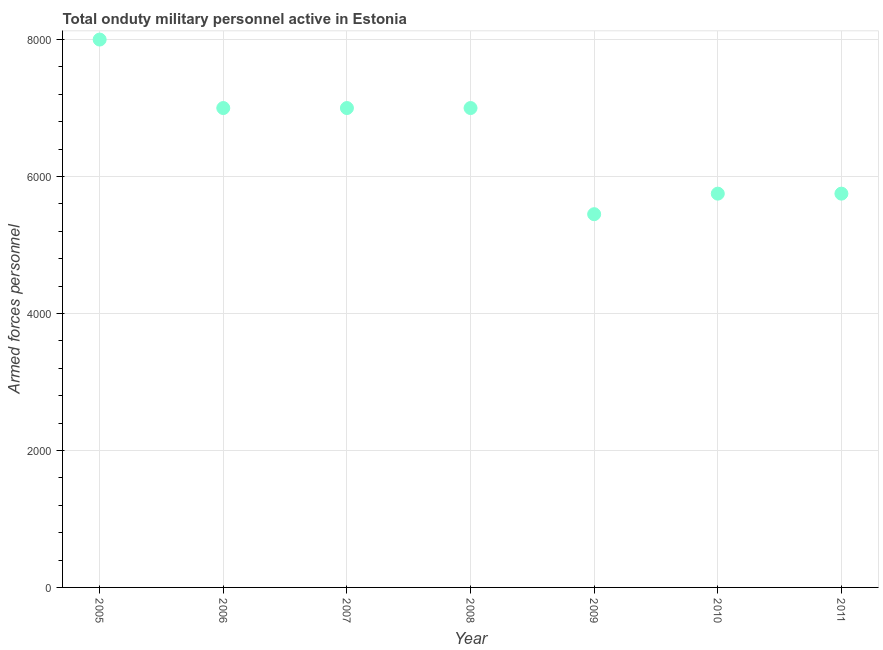What is the number of armed forces personnel in 2006?
Offer a very short reply. 7000. Across all years, what is the maximum number of armed forces personnel?
Provide a short and direct response. 8000. Across all years, what is the minimum number of armed forces personnel?
Your response must be concise. 5450. What is the sum of the number of armed forces personnel?
Give a very brief answer. 4.60e+04. What is the difference between the number of armed forces personnel in 2005 and 2006?
Provide a short and direct response. 1000. What is the average number of armed forces personnel per year?
Offer a very short reply. 6564.29. What is the median number of armed forces personnel?
Offer a terse response. 7000. In how many years, is the number of armed forces personnel greater than 1600 ?
Keep it short and to the point. 7. What is the ratio of the number of armed forces personnel in 2005 to that in 2010?
Your response must be concise. 1.39. Is the number of armed forces personnel in 2006 less than that in 2008?
Provide a succinct answer. No. Is the difference between the number of armed forces personnel in 2005 and 2011 greater than the difference between any two years?
Your answer should be very brief. No. What is the difference between the highest and the second highest number of armed forces personnel?
Keep it short and to the point. 1000. What is the difference between the highest and the lowest number of armed forces personnel?
Keep it short and to the point. 2550. In how many years, is the number of armed forces personnel greater than the average number of armed forces personnel taken over all years?
Keep it short and to the point. 4. How many dotlines are there?
Your answer should be very brief. 1. How many years are there in the graph?
Give a very brief answer. 7. Does the graph contain grids?
Provide a short and direct response. Yes. What is the title of the graph?
Give a very brief answer. Total onduty military personnel active in Estonia. What is the label or title of the X-axis?
Give a very brief answer. Year. What is the label or title of the Y-axis?
Provide a succinct answer. Armed forces personnel. What is the Armed forces personnel in 2005?
Your answer should be compact. 8000. What is the Armed forces personnel in 2006?
Your answer should be very brief. 7000. What is the Armed forces personnel in 2007?
Ensure brevity in your answer.  7000. What is the Armed forces personnel in 2008?
Provide a short and direct response. 7000. What is the Armed forces personnel in 2009?
Give a very brief answer. 5450. What is the Armed forces personnel in 2010?
Ensure brevity in your answer.  5750. What is the Armed forces personnel in 2011?
Offer a terse response. 5750. What is the difference between the Armed forces personnel in 2005 and 2006?
Provide a succinct answer. 1000. What is the difference between the Armed forces personnel in 2005 and 2007?
Ensure brevity in your answer.  1000. What is the difference between the Armed forces personnel in 2005 and 2008?
Offer a terse response. 1000. What is the difference between the Armed forces personnel in 2005 and 2009?
Your answer should be very brief. 2550. What is the difference between the Armed forces personnel in 2005 and 2010?
Give a very brief answer. 2250. What is the difference between the Armed forces personnel in 2005 and 2011?
Offer a terse response. 2250. What is the difference between the Armed forces personnel in 2006 and 2009?
Give a very brief answer. 1550. What is the difference between the Armed forces personnel in 2006 and 2010?
Your response must be concise. 1250. What is the difference between the Armed forces personnel in 2006 and 2011?
Offer a very short reply. 1250. What is the difference between the Armed forces personnel in 2007 and 2008?
Your answer should be very brief. 0. What is the difference between the Armed forces personnel in 2007 and 2009?
Provide a short and direct response. 1550. What is the difference between the Armed forces personnel in 2007 and 2010?
Make the answer very short. 1250. What is the difference between the Armed forces personnel in 2007 and 2011?
Provide a short and direct response. 1250. What is the difference between the Armed forces personnel in 2008 and 2009?
Your answer should be compact. 1550. What is the difference between the Armed forces personnel in 2008 and 2010?
Your answer should be very brief. 1250. What is the difference between the Armed forces personnel in 2008 and 2011?
Your response must be concise. 1250. What is the difference between the Armed forces personnel in 2009 and 2010?
Offer a very short reply. -300. What is the difference between the Armed forces personnel in 2009 and 2011?
Give a very brief answer. -300. What is the ratio of the Armed forces personnel in 2005 to that in 2006?
Make the answer very short. 1.14. What is the ratio of the Armed forces personnel in 2005 to that in 2007?
Keep it short and to the point. 1.14. What is the ratio of the Armed forces personnel in 2005 to that in 2008?
Keep it short and to the point. 1.14. What is the ratio of the Armed forces personnel in 2005 to that in 2009?
Your answer should be very brief. 1.47. What is the ratio of the Armed forces personnel in 2005 to that in 2010?
Keep it short and to the point. 1.39. What is the ratio of the Armed forces personnel in 2005 to that in 2011?
Your answer should be very brief. 1.39. What is the ratio of the Armed forces personnel in 2006 to that in 2007?
Make the answer very short. 1. What is the ratio of the Armed forces personnel in 2006 to that in 2009?
Make the answer very short. 1.28. What is the ratio of the Armed forces personnel in 2006 to that in 2010?
Your answer should be compact. 1.22. What is the ratio of the Armed forces personnel in 2006 to that in 2011?
Provide a short and direct response. 1.22. What is the ratio of the Armed forces personnel in 2007 to that in 2008?
Your answer should be very brief. 1. What is the ratio of the Armed forces personnel in 2007 to that in 2009?
Keep it short and to the point. 1.28. What is the ratio of the Armed forces personnel in 2007 to that in 2010?
Provide a succinct answer. 1.22. What is the ratio of the Armed forces personnel in 2007 to that in 2011?
Give a very brief answer. 1.22. What is the ratio of the Armed forces personnel in 2008 to that in 2009?
Your response must be concise. 1.28. What is the ratio of the Armed forces personnel in 2008 to that in 2010?
Ensure brevity in your answer.  1.22. What is the ratio of the Armed forces personnel in 2008 to that in 2011?
Offer a very short reply. 1.22. What is the ratio of the Armed forces personnel in 2009 to that in 2010?
Provide a succinct answer. 0.95. What is the ratio of the Armed forces personnel in 2009 to that in 2011?
Make the answer very short. 0.95. 